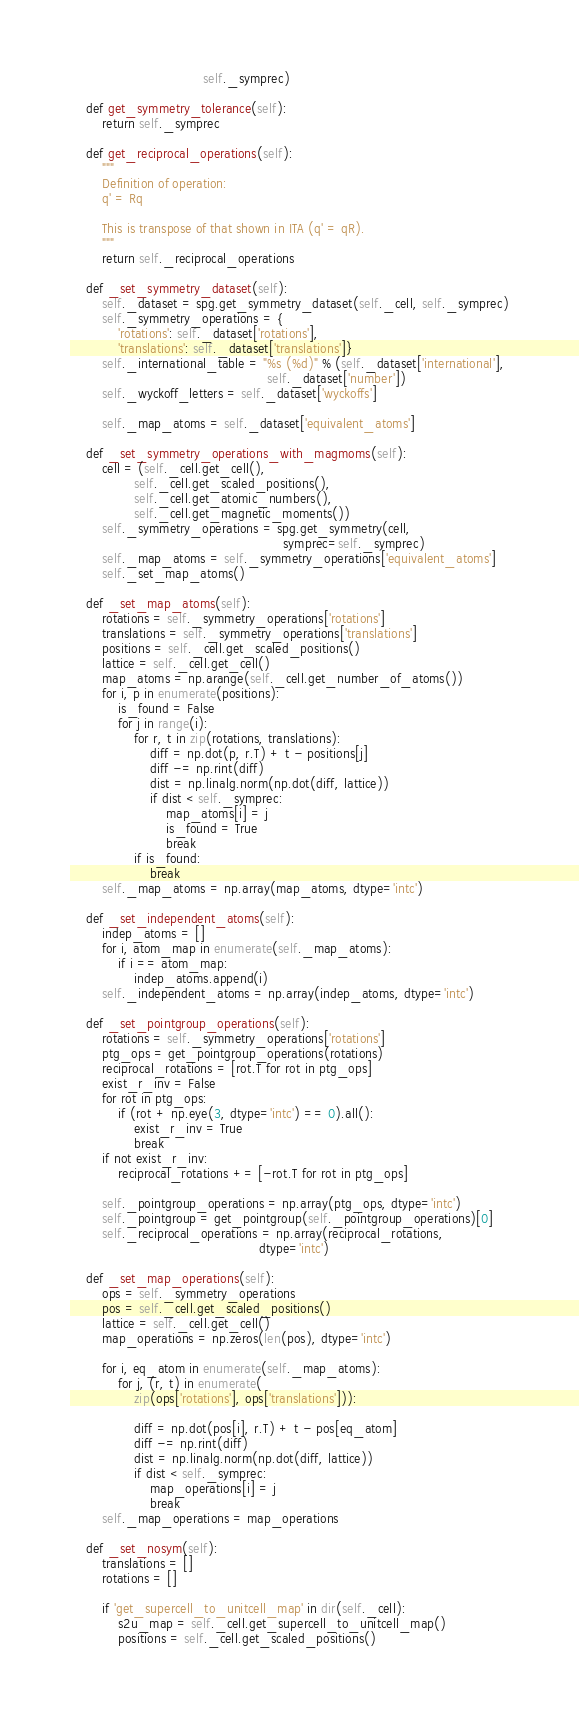Convert code to text. <code><loc_0><loc_0><loc_500><loc_500><_Python_>                                 self._symprec)

    def get_symmetry_tolerance(self):
        return self._symprec

    def get_reciprocal_operations(self):
        """
        Definition of operation:
        q' = Rq

        This is transpose of that shown in ITA (q' = qR).
        """
        return self._reciprocal_operations

    def _set_symmetry_dataset(self):
        self._dataset = spg.get_symmetry_dataset(self._cell, self._symprec)
        self._symmetry_operations = {
            'rotations': self._dataset['rotations'],
            'translations': self._dataset['translations']}
        self._international_table = "%s (%d)" % (self._dataset['international'],
                                                 self._dataset['number'])
        self._wyckoff_letters = self._dataset['wyckoffs']

        self._map_atoms = self._dataset['equivalent_atoms']

    def _set_symmetry_operations_with_magmoms(self):
        cell = (self._cell.get_cell(),
                self._cell.get_scaled_positions(),
                self._cell.get_atomic_numbers(),
                self._cell.get_magnetic_moments())
        self._symmetry_operations = spg.get_symmetry(cell,
                                                     symprec=self._symprec)
        self._map_atoms = self._symmetry_operations['equivalent_atoms']
        self._set_map_atoms()

    def _set_map_atoms(self):
        rotations = self._symmetry_operations['rotations']
        translations = self._symmetry_operations['translations']
        positions = self._cell.get_scaled_positions()
        lattice = self._cell.get_cell()
        map_atoms = np.arange(self._cell.get_number_of_atoms())
        for i, p in enumerate(positions):
            is_found = False
            for j in range(i):
                for r, t in zip(rotations, translations):
                    diff = np.dot(p, r.T) + t - positions[j]
                    diff -= np.rint(diff)
                    dist = np.linalg.norm(np.dot(diff, lattice))
                    if dist < self._symprec:
                        map_atoms[i] = j
                        is_found = True
                        break
                if is_found:
                    break
        self._map_atoms = np.array(map_atoms, dtype='intc')

    def _set_independent_atoms(self):
        indep_atoms = []
        for i, atom_map in enumerate(self._map_atoms):
            if i == atom_map:
                indep_atoms.append(i)
        self._independent_atoms = np.array(indep_atoms, dtype='intc')

    def _set_pointgroup_operations(self):
        rotations = self._symmetry_operations['rotations']
        ptg_ops = get_pointgroup_operations(rotations)
        reciprocal_rotations = [rot.T for rot in ptg_ops]
        exist_r_inv = False
        for rot in ptg_ops:
            if (rot + np.eye(3, dtype='intc') == 0).all():
                exist_r_inv = True
                break
        if not exist_r_inv:
            reciprocal_rotations += [-rot.T for rot in ptg_ops]

        self._pointgroup_operations = np.array(ptg_ops, dtype='intc')
        self._pointgroup = get_pointgroup(self._pointgroup_operations)[0]
        self._reciprocal_operations = np.array(reciprocal_rotations,
                                               dtype='intc')

    def _set_map_operations(self):
        ops = self._symmetry_operations
        pos = self._cell.get_scaled_positions()
        lattice = self._cell.get_cell()
        map_operations = np.zeros(len(pos), dtype='intc')

        for i, eq_atom in enumerate(self._map_atoms):
            for j, (r, t) in enumerate(
                zip(ops['rotations'], ops['translations'])):

                diff = np.dot(pos[i], r.T) + t - pos[eq_atom]
                diff -= np.rint(diff)
                dist = np.linalg.norm(np.dot(diff, lattice))
                if dist < self._symprec:
                    map_operations[i] = j
                    break
        self._map_operations = map_operations

    def _set_nosym(self):
        translations = []
        rotations = []

        if 'get_supercell_to_unitcell_map' in dir(self._cell):
            s2u_map = self._cell.get_supercell_to_unitcell_map()
            positions = self._cell.get_scaled_positions()
</code> 